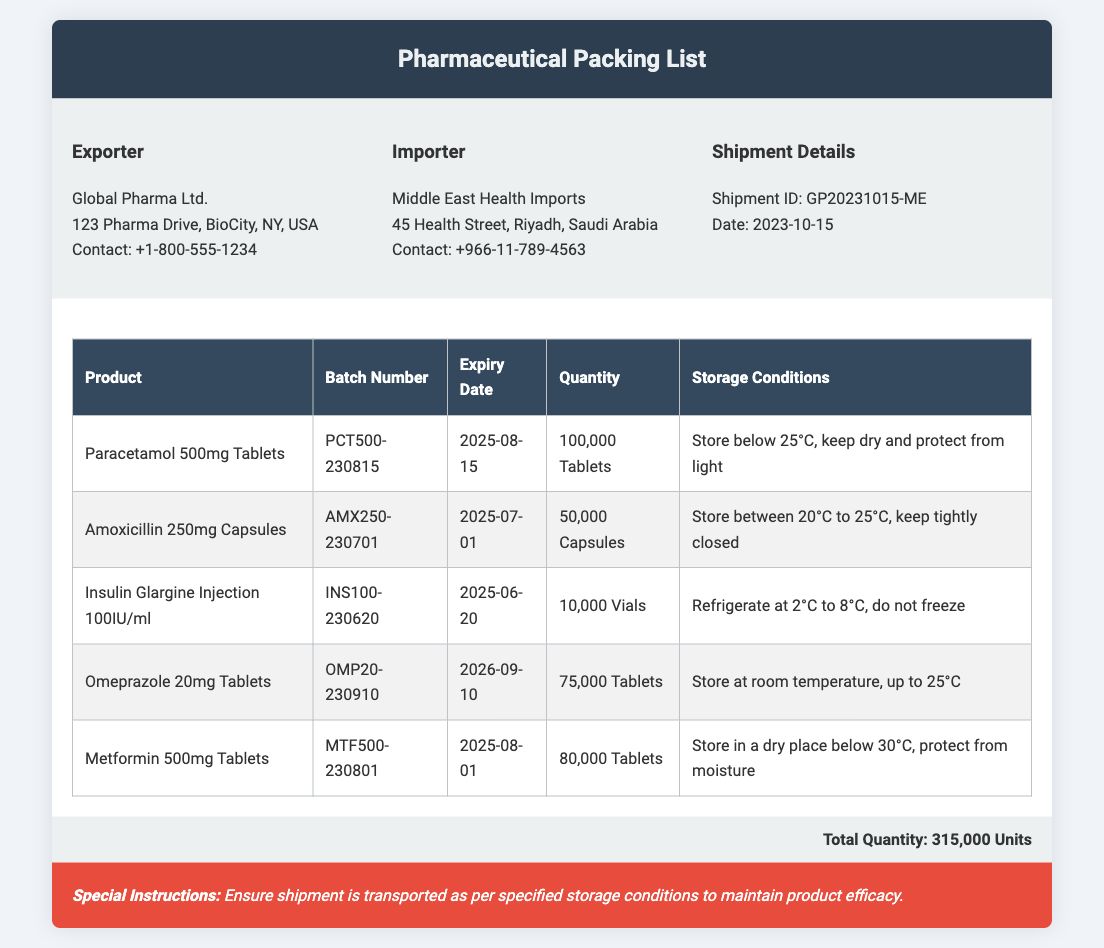What is the name of the exporter? The exporter's name is listed in the company details section of the document.
Answer: Global Pharma Ltd What is the shipment ID? The shipment ID is provided under the shipment details section of the document.
Answer: GP20231015-ME How many vials of Insulin Glargine Injection are included? The quantity of Insulin Glargine Injection is mentioned in the products table.
Answer: 10,000 Vials What is the storage condition for Amoxicillin 250mg Capsules? The storage conditions for Amoxicillin are detailed in the products table.
Answer: Store between 20°C to 25°C, keep tightly closed What is the expiry date of Paracetamol 500mg Tablets? The expiry date for Paracetamol is specified in the products table.
Answer: 2025-08-15 What is the total quantity of units listed in the packing list? The total quantity is given in the total quantity section at the bottom of the document.
Answer: 315,000 Units How many products are listed in the packing list? The number of products can be counted from the rows in the products table.
Answer: 5 What special instructions are provided for the shipment? The special instructions section outlines the requirements for the shipment.
Answer: Ensure shipment is transported as per specified storage conditions to maintain product efficacy Which product has the earliest expiry date? The expiry dates for each product need to be compared to determine the earliest one.
Answer: Insulin Glargine Injection 100IU/ml (2025-06-20) 